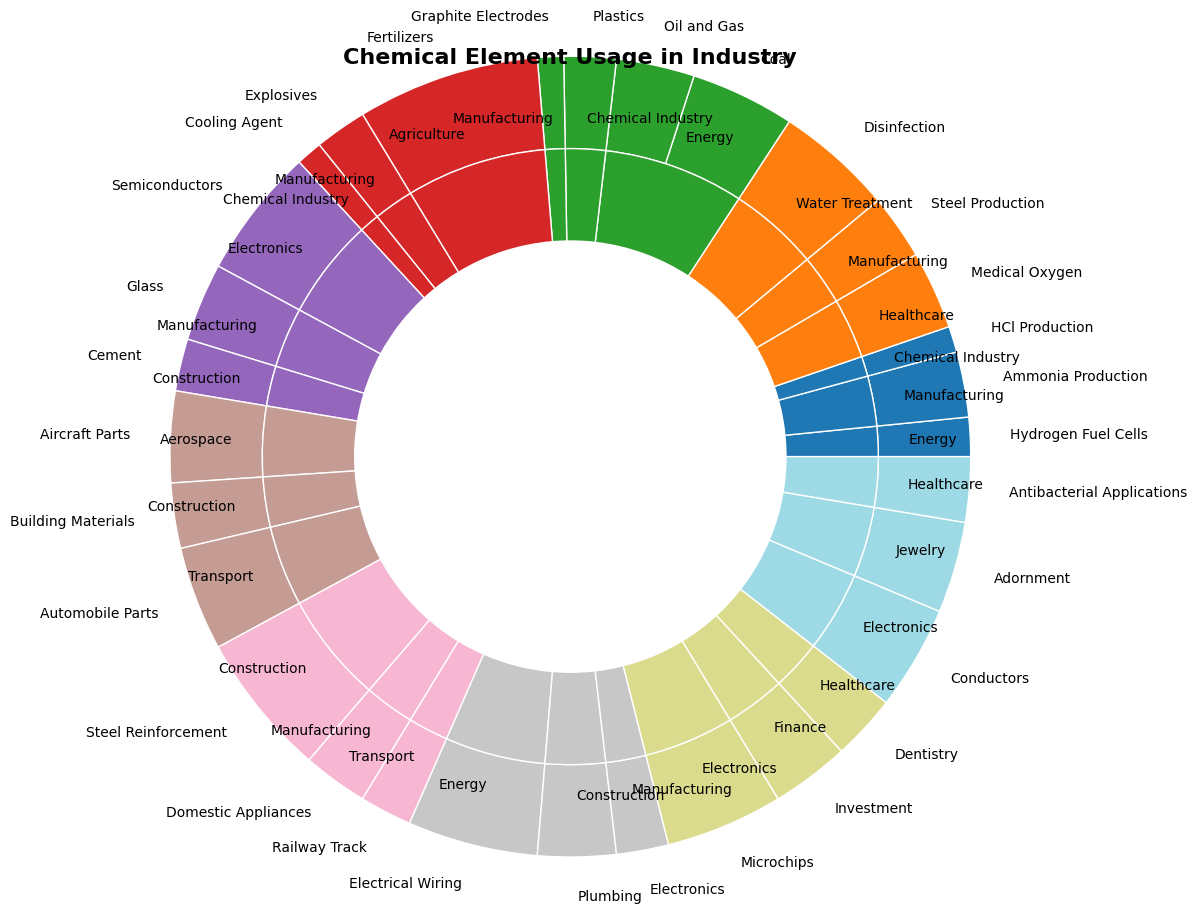What chemical element is most used in the energy sector? By examining the slices in the energy sector, the largest slice belongs to Carbon, which has significant portions for Coal and Oil and Gas.
Answer: Carbon Which sector uses the highest percentage of Oxygen? The Water Treatment sector has the largest portion of Oxygen usage, indicated by the biggest slice labeled "Disinfection."
Answer: Water Treatment What is the combined percentage of the Construction sector for Aluminum and Iron? The Construction sector for Aluminum is 25% and for Iron is 55%. Summing them gives 25% + 55% = 80%.
Answer: 80% For the element Hydrogen, which application has the smallest usage percentage? The smallest slice related to Hydrogen is labeled "HCl Production" under the Chemical Industry sector.
Answer: HCl Production Compare the percentages of Electrical Wiring and Plumbing for Copper. Which is higher? Electrical Wiring has a larger slice compared to Plumbing for Copper. Electrical Wiring is 50%, and Plumbing is 30%.
Answer: Electrical Wiring How does the usage of Nitrogen in Agriculture compare to its usage in Manufacturing? The slice for Nitrogen in Agriculture (Fertilizers) is much larger (70%) compared to Nitrogen in Manufacturing (Explosives), which is 20%.
Answer: Agriculture is higher What is the visual proportion of Carbon used in the Chemical Industry? Examining the slices for Carbon, the Chemical Industry sector labeled "Plastics" forms a moderately visible slice amongst the other Carbon applications. It's 20%.
Answer: 20% What percentage of the Healthcare sector is devoted to Silver? The Healthcare sector under Silver is indicated by the slice labeled "Antibacterial Applications," which is 25%.
Answer: 25% For Silicon, which application dominates its usage? Among the slices for Silicon, Electronics for "Semiconductors" has the largest portion, which is 50%.
Answer: Semiconductors Which sector utilizes Aluminum the most, and by what percentage? The Transport sector uses Aluminum the most, evident by the largest slice labeled "Automobile Parts," which is 40%.
Answer: Transport at 40% 